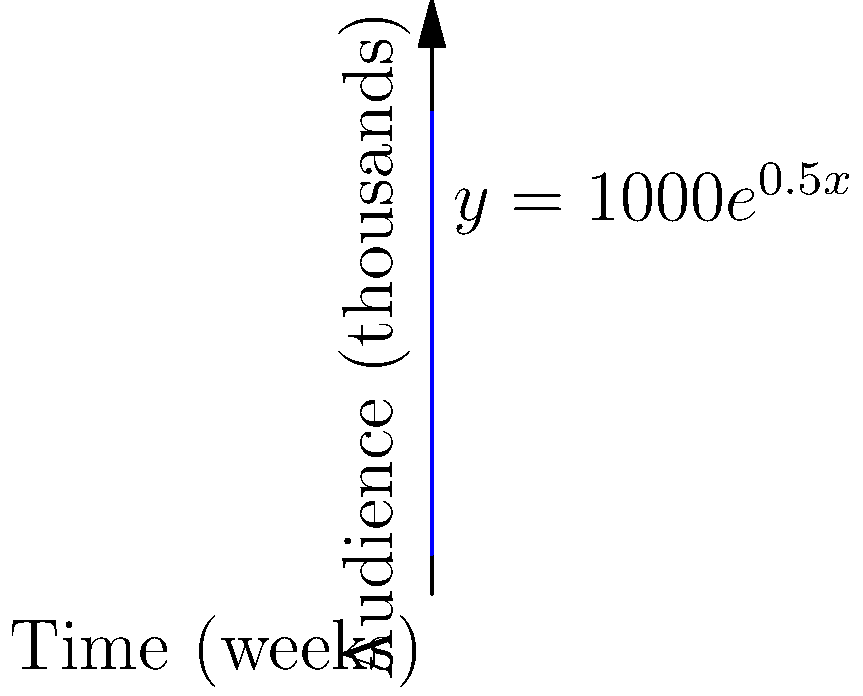As a film director, you're tracking the audience growth of your latest film. The graph shows the exponential growth of your audience over time, represented by the function $y = 1000e^{0.5x}$, where $y$ is the audience size in thousands and $x$ is the time in weeks. After how many weeks will your film reach an audience of 10,000,000 people? Let's approach this step-by-step:

1) We need to find $x$ when $y = 10,000,000$.

2) The function is $y = 1000e^{0.5x}$.

3) Substituting $y$ with 10,000,000:
   $10,000,000 = 1000e^{0.5x}$

4) Divide both sides by 1000:
   $10,000 = e^{0.5x}$

5) Take the natural log of both sides:
   $\ln(10,000) = \ln(e^{0.5x})$

6) Simplify the right side using the property of logarithms:
   $\ln(10,000) = 0.5x$

7) Calculate $\ln(10,000)$:
   $9.21 = 0.5x$

8) Multiply both sides by 2:
   $18.42 = x$

Therefore, it will take approximately 18.42 weeks for the film to reach an audience of 10,000,000 people.
Answer: 18.42 weeks 